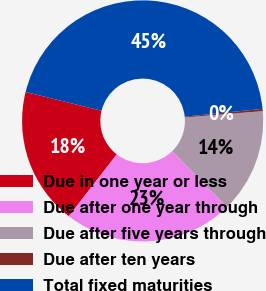<chart> <loc_0><loc_0><loc_500><loc_500><pie_chart><fcel>Due in one year or less<fcel>Due after one year through<fcel>Due after five years through<fcel>Due after ten years<fcel>Total fixed maturities<nl><fcel>18.38%<fcel>22.81%<fcel>13.96%<fcel>0.3%<fcel>44.55%<nl></chart> 